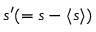Convert formula to latex. <formula><loc_0><loc_0><loc_500><loc_500>s ^ { \prime } ( = s - \langle { s } \rangle )</formula> 